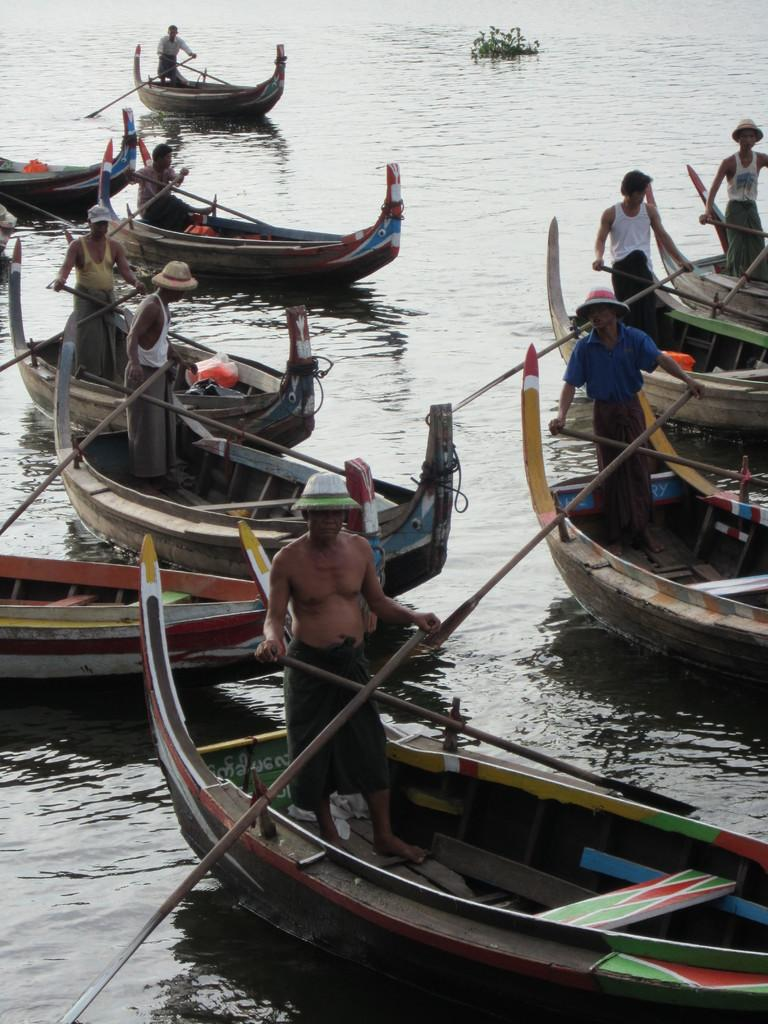What is happening in the image? There are people in the image, and they are standing in individual boats. Where are the boats located? The boats are on the water. What type of poison is being used by the people in the boats? There is no indication of any poison being used in the image; the people are simply standing in individual boats on the water. 